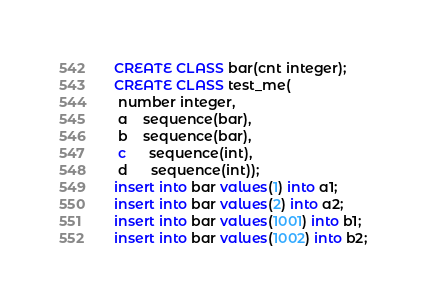<code> <loc_0><loc_0><loc_500><loc_500><_SQL_>CREATE CLASS bar(cnt integer);
CREATE CLASS test_me(
 number integer,
 a	sequence(bar),
 b	sequence(bar),
 c      sequence(int),
 d      sequence(int));
insert into bar values(1) into a1;
insert into bar values(2) into a2;
insert into bar values(1001) into b1;
insert into bar values(1002) into b2;</code> 